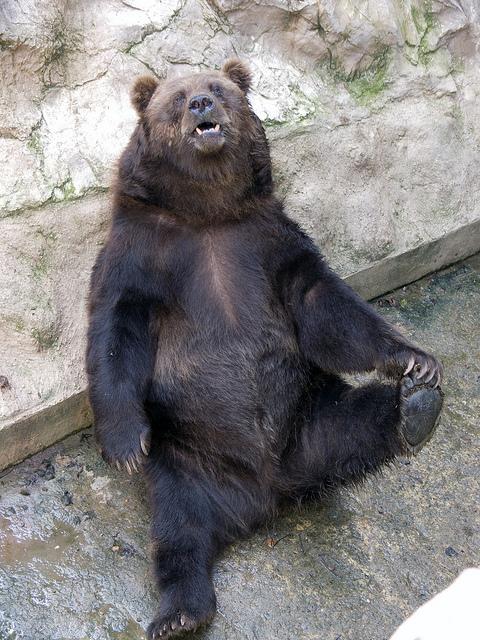Is that a dog?
Keep it brief. No. Is this bear sleeping?
Quick response, please. No. What color is the bear?
Short answer required. Brown. 